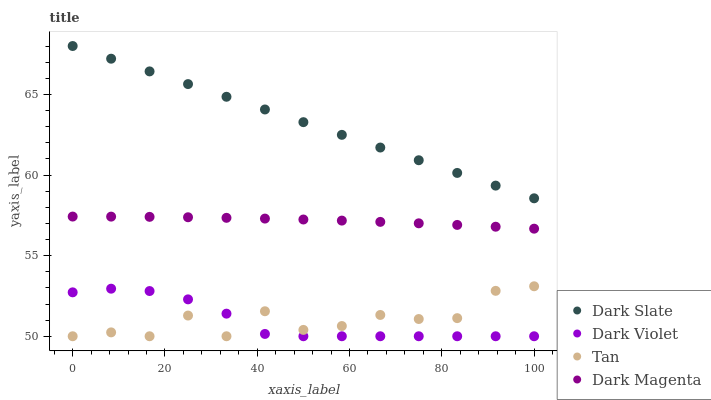Does Dark Violet have the minimum area under the curve?
Answer yes or no. Yes. Does Dark Slate have the maximum area under the curve?
Answer yes or no. Yes. Does Tan have the minimum area under the curve?
Answer yes or no. No. Does Tan have the maximum area under the curve?
Answer yes or no. No. Is Dark Slate the smoothest?
Answer yes or no. Yes. Is Tan the roughest?
Answer yes or no. Yes. Is Dark Magenta the smoothest?
Answer yes or no. No. Is Dark Magenta the roughest?
Answer yes or no. No. Does Tan have the lowest value?
Answer yes or no. Yes. Does Dark Magenta have the lowest value?
Answer yes or no. No. Does Dark Slate have the highest value?
Answer yes or no. Yes. Does Tan have the highest value?
Answer yes or no. No. Is Tan less than Dark Slate?
Answer yes or no. Yes. Is Dark Slate greater than Dark Violet?
Answer yes or no. Yes. Does Dark Violet intersect Tan?
Answer yes or no. Yes. Is Dark Violet less than Tan?
Answer yes or no. No. Is Dark Violet greater than Tan?
Answer yes or no. No. Does Tan intersect Dark Slate?
Answer yes or no. No. 